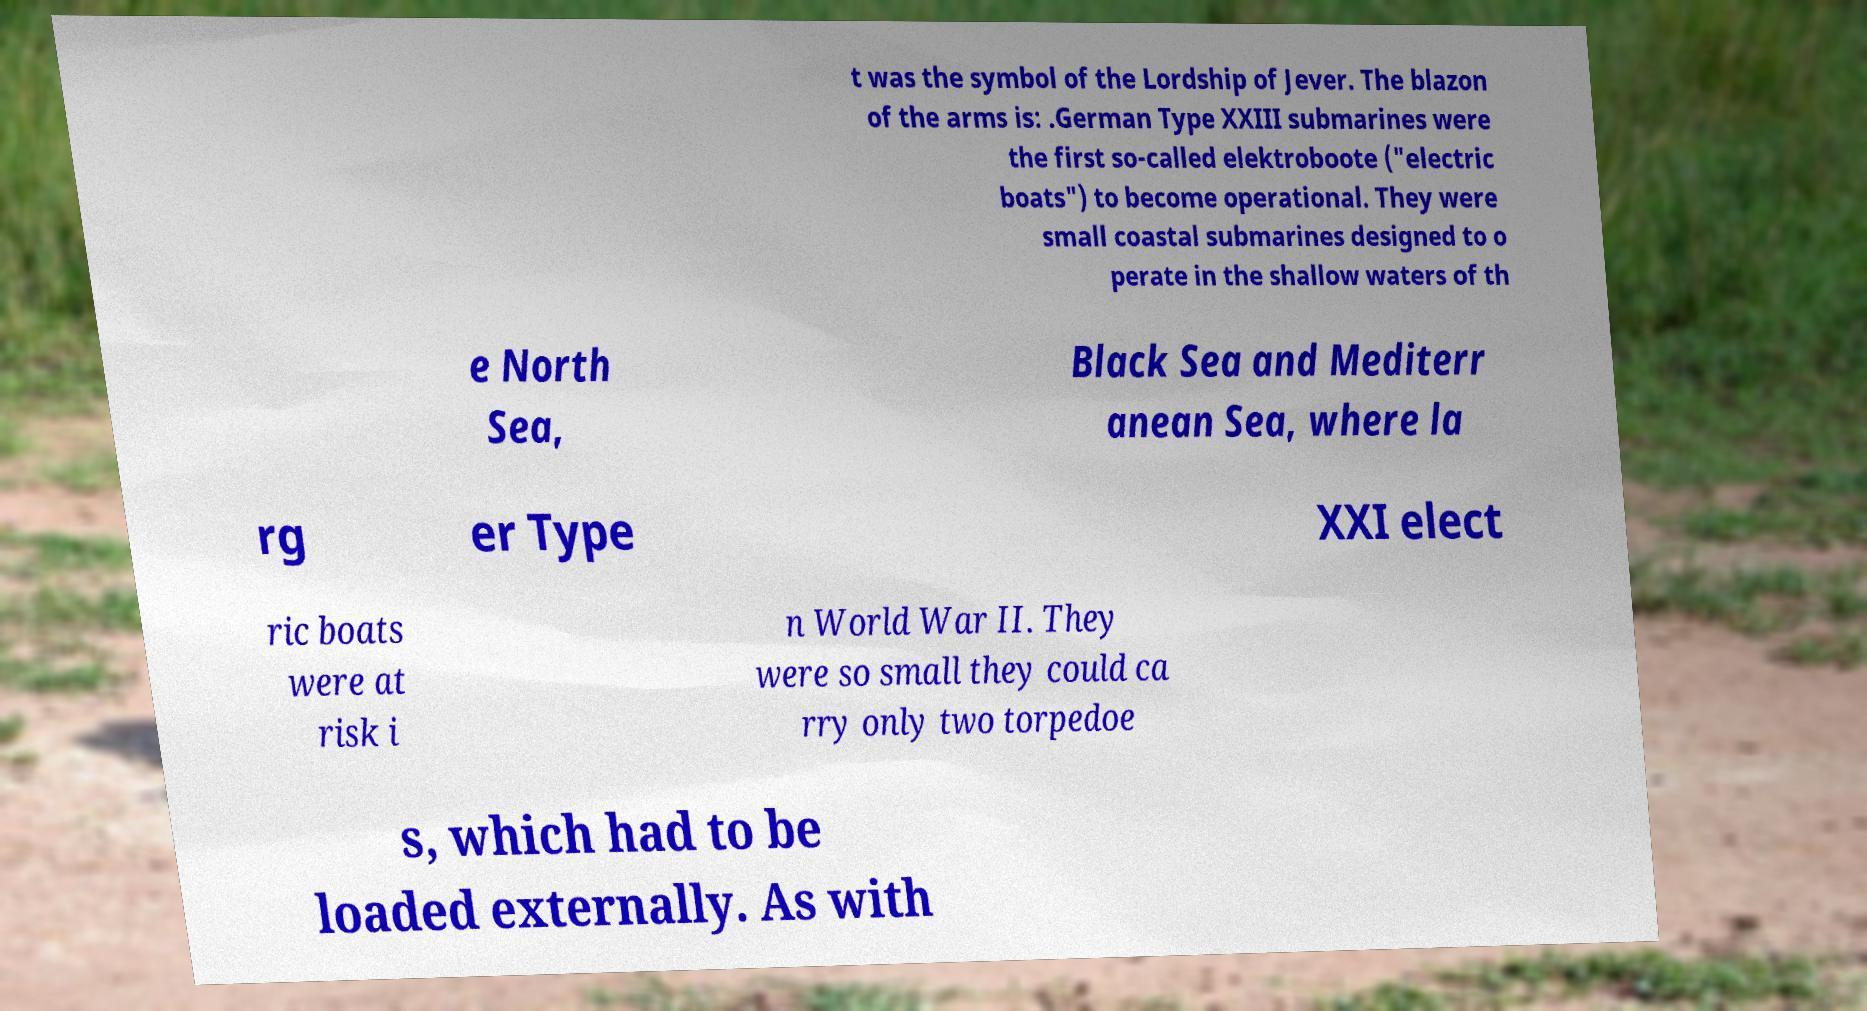What messages or text are displayed in this image? I need them in a readable, typed format. t was the symbol of the Lordship of Jever. The blazon of the arms is: .German Type XXIII submarines were the first so-called elektroboote ("electric boats") to become operational. They were small coastal submarines designed to o perate in the shallow waters of th e North Sea, Black Sea and Mediterr anean Sea, where la rg er Type XXI elect ric boats were at risk i n World War II. They were so small they could ca rry only two torpedoe s, which had to be loaded externally. As with 